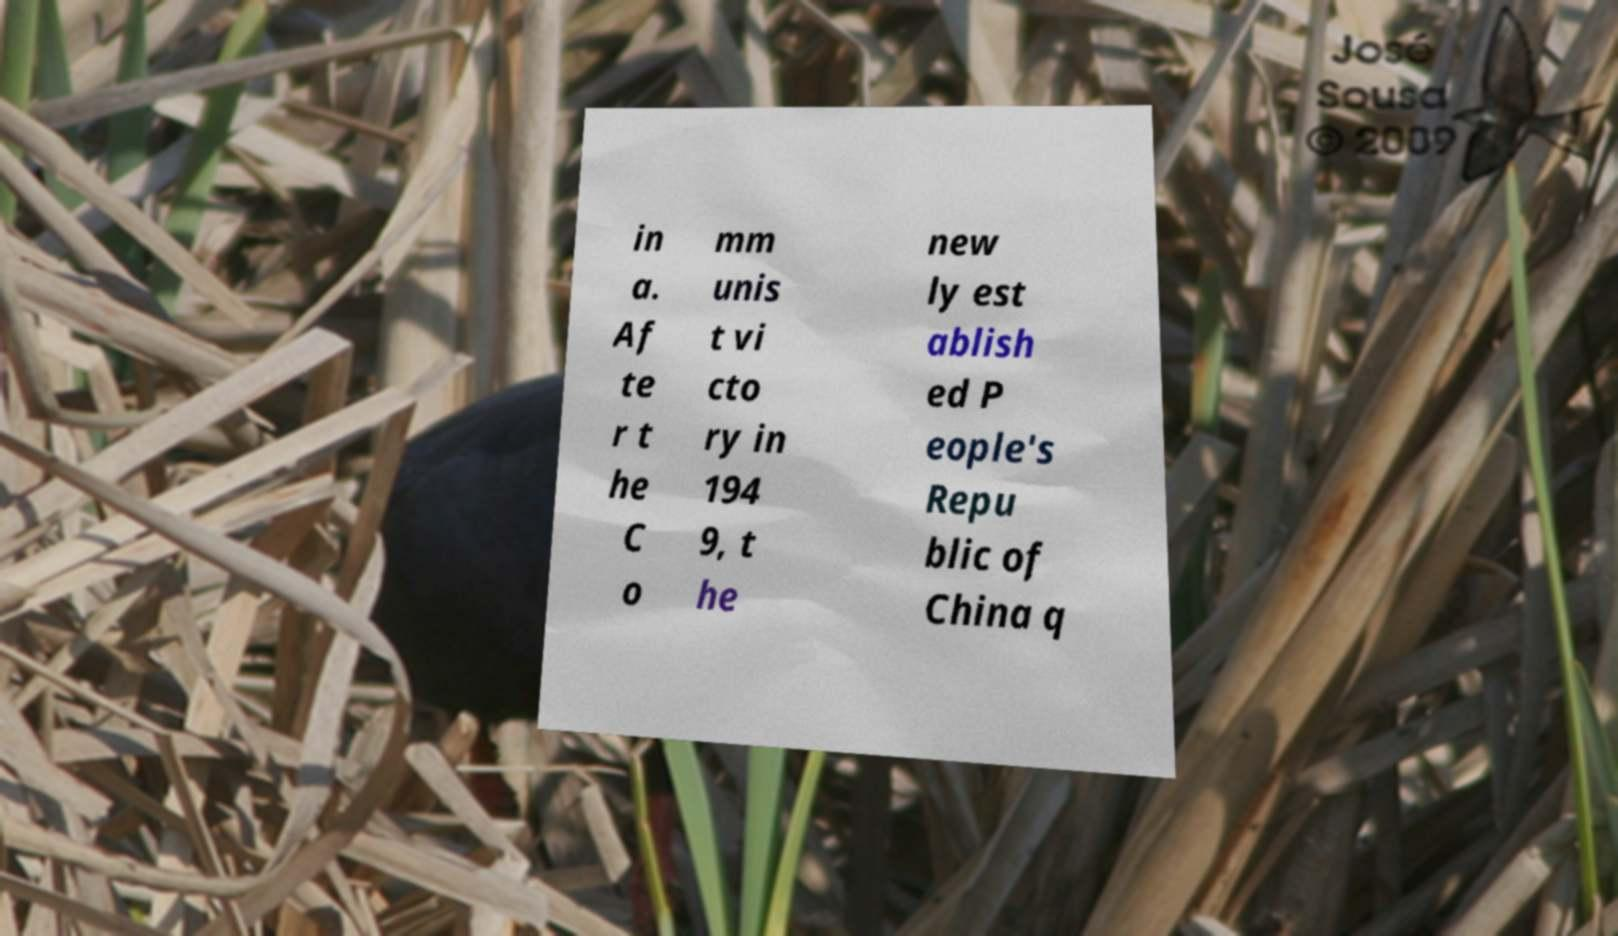Can you accurately transcribe the text from the provided image for me? in a. Af te r t he C o mm unis t vi cto ry in 194 9, t he new ly est ablish ed P eople's Repu blic of China q 